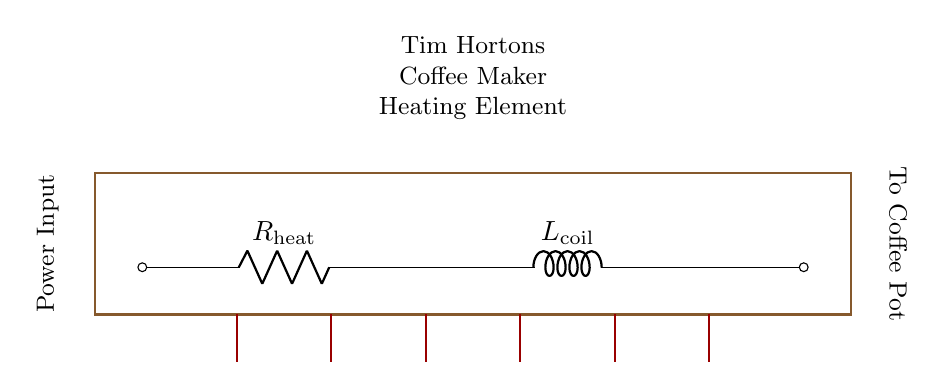What are the main components in this circuit? The main components are a resistor and an inductor, which are labeled in the diagram as R for the resistor and L for the inductor.
Answer: Resistor and Inductor What is the purpose of the heating element in the circuit? The heating element serves to heat the water in the coffee maker, which is essential for brewing coffee. This is accomplished by converting electrical energy into thermal energy in the resistor.
Answer: To heat water What does R represent in the circuit? R represents the resistance encountered by the electrical current flowing through the heating element. It determines how much current flows for a given voltage according to Ohm's law.
Answer: Resistance How does the inductor behave when the circuit is powered? An inductor opposes changes in current. When power is applied, it will initially resist the change in current but will allow a steady current to flow after a brief time, creating a magnetic field.
Answer: Opposes current change What is the effect of combining a resistor and an inductor in this circuit? The combination creates an RL circuit that affects the overall resistance and inductance, leading to specific time constants for how quickly the circuit responds to changes in voltage and current. The overall impedance will be greater than the resistor alone.
Answer: Inductive reactance What happens to the current at the start when the coffee maker is turned on? At the start, the current in the circuit gradually increases due to the inductive property of the coil, which opposes the initial change in current, resulting in a delay.
Answer: Gradually increases What is the expected outcome if the resistor were to fail open? If the resistor fails open, no current would flow through the circuit, and the heating element would not function, preventing the coffee maker from brewing coffee.
Answer: No coffee brewing 